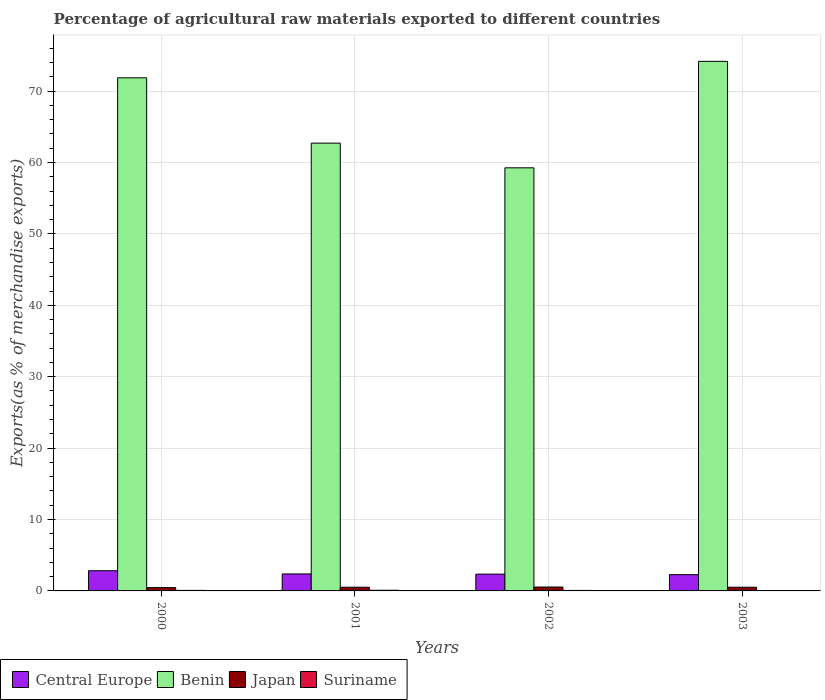Are the number of bars on each tick of the X-axis equal?
Offer a terse response. Yes. How many bars are there on the 1st tick from the right?
Offer a very short reply. 4. What is the label of the 1st group of bars from the left?
Make the answer very short. 2000. In how many cases, is the number of bars for a given year not equal to the number of legend labels?
Your answer should be very brief. 0. What is the percentage of exports to different countries in Suriname in 2002?
Your response must be concise. 0.07. Across all years, what is the maximum percentage of exports to different countries in Central Europe?
Offer a very short reply. 2.83. Across all years, what is the minimum percentage of exports to different countries in Suriname?
Make the answer very short. 0.05. In which year was the percentage of exports to different countries in Central Europe maximum?
Ensure brevity in your answer.  2000. What is the total percentage of exports to different countries in Benin in the graph?
Your answer should be very brief. 268. What is the difference between the percentage of exports to different countries in Benin in 2000 and that in 2003?
Your answer should be very brief. -2.3. What is the difference between the percentage of exports to different countries in Japan in 2001 and the percentage of exports to different countries in Suriname in 2002?
Offer a very short reply. 0.45. What is the average percentage of exports to different countries in Japan per year?
Your answer should be very brief. 0.51. In the year 2000, what is the difference between the percentage of exports to different countries in Suriname and percentage of exports to different countries in Japan?
Offer a very short reply. -0.39. What is the ratio of the percentage of exports to different countries in Benin in 2002 to that in 2003?
Your response must be concise. 0.8. What is the difference between the highest and the second highest percentage of exports to different countries in Japan?
Offer a terse response. 0.02. What is the difference between the highest and the lowest percentage of exports to different countries in Suriname?
Give a very brief answer. 0.05. In how many years, is the percentage of exports to different countries in Central Europe greater than the average percentage of exports to different countries in Central Europe taken over all years?
Keep it short and to the point. 1. Is it the case that in every year, the sum of the percentage of exports to different countries in Benin and percentage of exports to different countries in Central Europe is greater than the sum of percentage of exports to different countries in Japan and percentage of exports to different countries in Suriname?
Your answer should be very brief. Yes. What does the 2nd bar from the left in 2003 represents?
Offer a very short reply. Benin. What does the 3rd bar from the right in 2003 represents?
Keep it short and to the point. Benin. How many bars are there?
Keep it short and to the point. 16. What is the difference between two consecutive major ticks on the Y-axis?
Your response must be concise. 10. Are the values on the major ticks of Y-axis written in scientific E-notation?
Your answer should be compact. No. Does the graph contain any zero values?
Offer a very short reply. No. Where does the legend appear in the graph?
Offer a terse response. Bottom left. What is the title of the graph?
Your response must be concise. Percentage of agricultural raw materials exported to different countries. What is the label or title of the Y-axis?
Give a very brief answer. Exports(as % of merchandise exports). What is the Exports(as % of merchandise exports) of Central Europe in 2000?
Your answer should be compact. 2.83. What is the Exports(as % of merchandise exports) of Benin in 2000?
Offer a very short reply. 71.86. What is the Exports(as % of merchandise exports) of Japan in 2000?
Provide a succinct answer. 0.46. What is the Exports(as % of merchandise exports) in Suriname in 2000?
Provide a succinct answer. 0.08. What is the Exports(as % of merchandise exports) of Central Europe in 2001?
Your answer should be compact. 2.38. What is the Exports(as % of merchandise exports) in Benin in 2001?
Give a very brief answer. 62.71. What is the Exports(as % of merchandise exports) in Japan in 2001?
Keep it short and to the point. 0.52. What is the Exports(as % of merchandise exports) in Suriname in 2001?
Your response must be concise. 0.09. What is the Exports(as % of merchandise exports) in Central Europe in 2002?
Provide a succinct answer. 2.35. What is the Exports(as % of merchandise exports) in Benin in 2002?
Your answer should be very brief. 59.25. What is the Exports(as % of merchandise exports) in Japan in 2002?
Make the answer very short. 0.54. What is the Exports(as % of merchandise exports) of Suriname in 2002?
Make the answer very short. 0.07. What is the Exports(as % of merchandise exports) of Central Europe in 2003?
Your answer should be very brief. 2.28. What is the Exports(as % of merchandise exports) of Benin in 2003?
Offer a very short reply. 74.17. What is the Exports(as % of merchandise exports) of Japan in 2003?
Your answer should be compact. 0.52. What is the Exports(as % of merchandise exports) in Suriname in 2003?
Provide a short and direct response. 0.05. Across all years, what is the maximum Exports(as % of merchandise exports) in Central Europe?
Offer a terse response. 2.83. Across all years, what is the maximum Exports(as % of merchandise exports) in Benin?
Your answer should be very brief. 74.17. Across all years, what is the maximum Exports(as % of merchandise exports) of Japan?
Your answer should be very brief. 0.54. Across all years, what is the maximum Exports(as % of merchandise exports) in Suriname?
Keep it short and to the point. 0.09. Across all years, what is the minimum Exports(as % of merchandise exports) in Central Europe?
Your response must be concise. 2.28. Across all years, what is the minimum Exports(as % of merchandise exports) of Benin?
Ensure brevity in your answer.  59.25. Across all years, what is the minimum Exports(as % of merchandise exports) of Japan?
Your answer should be compact. 0.46. Across all years, what is the minimum Exports(as % of merchandise exports) in Suriname?
Keep it short and to the point. 0.05. What is the total Exports(as % of merchandise exports) in Central Europe in the graph?
Keep it short and to the point. 9.83. What is the total Exports(as % of merchandise exports) in Benin in the graph?
Offer a very short reply. 268. What is the total Exports(as % of merchandise exports) of Japan in the graph?
Offer a very short reply. 2.05. What is the total Exports(as % of merchandise exports) in Suriname in the graph?
Ensure brevity in your answer.  0.29. What is the difference between the Exports(as % of merchandise exports) of Central Europe in 2000 and that in 2001?
Your response must be concise. 0.45. What is the difference between the Exports(as % of merchandise exports) of Benin in 2000 and that in 2001?
Provide a short and direct response. 9.15. What is the difference between the Exports(as % of merchandise exports) of Japan in 2000 and that in 2001?
Keep it short and to the point. -0.06. What is the difference between the Exports(as % of merchandise exports) of Suriname in 2000 and that in 2001?
Your answer should be compact. -0.02. What is the difference between the Exports(as % of merchandise exports) of Central Europe in 2000 and that in 2002?
Your response must be concise. 0.48. What is the difference between the Exports(as % of merchandise exports) in Benin in 2000 and that in 2002?
Provide a succinct answer. 12.61. What is the difference between the Exports(as % of merchandise exports) in Japan in 2000 and that in 2002?
Provide a succinct answer. -0.08. What is the difference between the Exports(as % of merchandise exports) of Suriname in 2000 and that in 2002?
Make the answer very short. 0.01. What is the difference between the Exports(as % of merchandise exports) in Central Europe in 2000 and that in 2003?
Your answer should be very brief. 0.55. What is the difference between the Exports(as % of merchandise exports) in Benin in 2000 and that in 2003?
Give a very brief answer. -2.3. What is the difference between the Exports(as % of merchandise exports) of Japan in 2000 and that in 2003?
Provide a short and direct response. -0.05. What is the difference between the Exports(as % of merchandise exports) of Suriname in 2000 and that in 2003?
Provide a succinct answer. 0.03. What is the difference between the Exports(as % of merchandise exports) in Central Europe in 2001 and that in 2002?
Keep it short and to the point. 0.03. What is the difference between the Exports(as % of merchandise exports) of Benin in 2001 and that in 2002?
Your answer should be very brief. 3.46. What is the difference between the Exports(as % of merchandise exports) in Japan in 2001 and that in 2002?
Provide a short and direct response. -0.02. What is the difference between the Exports(as % of merchandise exports) of Suriname in 2001 and that in 2002?
Provide a succinct answer. 0.03. What is the difference between the Exports(as % of merchandise exports) of Central Europe in 2001 and that in 2003?
Give a very brief answer. 0.1. What is the difference between the Exports(as % of merchandise exports) in Benin in 2001 and that in 2003?
Offer a very short reply. -11.45. What is the difference between the Exports(as % of merchandise exports) of Japan in 2001 and that in 2003?
Give a very brief answer. 0. What is the difference between the Exports(as % of merchandise exports) in Suriname in 2001 and that in 2003?
Keep it short and to the point. 0.05. What is the difference between the Exports(as % of merchandise exports) of Central Europe in 2002 and that in 2003?
Make the answer very short. 0.07. What is the difference between the Exports(as % of merchandise exports) in Benin in 2002 and that in 2003?
Ensure brevity in your answer.  -14.91. What is the difference between the Exports(as % of merchandise exports) of Japan in 2002 and that in 2003?
Your response must be concise. 0.02. What is the difference between the Exports(as % of merchandise exports) of Suriname in 2002 and that in 2003?
Offer a terse response. 0.02. What is the difference between the Exports(as % of merchandise exports) in Central Europe in 2000 and the Exports(as % of merchandise exports) in Benin in 2001?
Offer a very short reply. -59.88. What is the difference between the Exports(as % of merchandise exports) of Central Europe in 2000 and the Exports(as % of merchandise exports) of Japan in 2001?
Your answer should be compact. 2.31. What is the difference between the Exports(as % of merchandise exports) in Central Europe in 2000 and the Exports(as % of merchandise exports) in Suriname in 2001?
Provide a succinct answer. 2.74. What is the difference between the Exports(as % of merchandise exports) in Benin in 2000 and the Exports(as % of merchandise exports) in Japan in 2001?
Offer a very short reply. 71.34. What is the difference between the Exports(as % of merchandise exports) in Benin in 2000 and the Exports(as % of merchandise exports) in Suriname in 2001?
Offer a terse response. 71.77. What is the difference between the Exports(as % of merchandise exports) of Japan in 2000 and the Exports(as % of merchandise exports) of Suriname in 2001?
Provide a succinct answer. 0.37. What is the difference between the Exports(as % of merchandise exports) in Central Europe in 2000 and the Exports(as % of merchandise exports) in Benin in 2002?
Your answer should be very brief. -56.43. What is the difference between the Exports(as % of merchandise exports) in Central Europe in 2000 and the Exports(as % of merchandise exports) in Japan in 2002?
Give a very brief answer. 2.29. What is the difference between the Exports(as % of merchandise exports) of Central Europe in 2000 and the Exports(as % of merchandise exports) of Suriname in 2002?
Your answer should be very brief. 2.76. What is the difference between the Exports(as % of merchandise exports) in Benin in 2000 and the Exports(as % of merchandise exports) in Japan in 2002?
Offer a very short reply. 71.32. What is the difference between the Exports(as % of merchandise exports) in Benin in 2000 and the Exports(as % of merchandise exports) in Suriname in 2002?
Offer a very short reply. 71.79. What is the difference between the Exports(as % of merchandise exports) of Japan in 2000 and the Exports(as % of merchandise exports) of Suriname in 2002?
Provide a succinct answer. 0.4. What is the difference between the Exports(as % of merchandise exports) in Central Europe in 2000 and the Exports(as % of merchandise exports) in Benin in 2003?
Provide a succinct answer. -71.34. What is the difference between the Exports(as % of merchandise exports) of Central Europe in 2000 and the Exports(as % of merchandise exports) of Japan in 2003?
Your answer should be very brief. 2.31. What is the difference between the Exports(as % of merchandise exports) in Central Europe in 2000 and the Exports(as % of merchandise exports) in Suriname in 2003?
Your answer should be compact. 2.78. What is the difference between the Exports(as % of merchandise exports) in Benin in 2000 and the Exports(as % of merchandise exports) in Japan in 2003?
Your answer should be very brief. 71.34. What is the difference between the Exports(as % of merchandise exports) of Benin in 2000 and the Exports(as % of merchandise exports) of Suriname in 2003?
Your answer should be compact. 71.82. What is the difference between the Exports(as % of merchandise exports) in Japan in 2000 and the Exports(as % of merchandise exports) in Suriname in 2003?
Provide a short and direct response. 0.42. What is the difference between the Exports(as % of merchandise exports) of Central Europe in 2001 and the Exports(as % of merchandise exports) of Benin in 2002?
Your answer should be very brief. -56.88. What is the difference between the Exports(as % of merchandise exports) in Central Europe in 2001 and the Exports(as % of merchandise exports) in Japan in 2002?
Keep it short and to the point. 1.83. What is the difference between the Exports(as % of merchandise exports) of Central Europe in 2001 and the Exports(as % of merchandise exports) of Suriname in 2002?
Give a very brief answer. 2.31. What is the difference between the Exports(as % of merchandise exports) of Benin in 2001 and the Exports(as % of merchandise exports) of Japan in 2002?
Offer a very short reply. 62.17. What is the difference between the Exports(as % of merchandise exports) of Benin in 2001 and the Exports(as % of merchandise exports) of Suriname in 2002?
Give a very brief answer. 62.65. What is the difference between the Exports(as % of merchandise exports) in Japan in 2001 and the Exports(as % of merchandise exports) in Suriname in 2002?
Your response must be concise. 0.45. What is the difference between the Exports(as % of merchandise exports) in Central Europe in 2001 and the Exports(as % of merchandise exports) in Benin in 2003?
Give a very brief answer. -71.79. What is the difference between the Exports(as % of merchandise exports) of Central Europe in 2001 and the Exports(as % of merchandise exports) of Japan in 2003?
Offer a terse response. 1.86. What is the difference between the Exports(as % of merchandise exports) in Central Europe in 2001 and the Exports(as % of merchandise exports) in Suriname in 2003?
Provide a short and direct response. 2.33. What is the difference between the Exports(as % of merchandise exports) in Benin in 2001 and the Exports(as % of merchandise exports) in Japan in 2003?
Offer a very short reply. 62.2. What is the difference between the Exports(as % of merchandise exports) of Benin in 2001 and the Exports(as % of merchandise exports) of Suriname in 2003?
Your response must be concise. 62.67. What is the difference between the Exports(as % of merchandise exports) of Japan in 2001 and the Exports(as % of merchandise exports) of Suriname in 2003?
Your answer should be very brief. 0.47. What is the difference between the Exports(as % of merchandise exports) in Central Europe in 2002 and the Exports(as % of merchandise exports) in Benin in 2003?
Your answer should be compact. -71.82. What is the difference between the Exports(as % of merchandise exports) in Central Europe in 2002 and the Exports(as % of merchandise exports) in Japan in 2003?
Provide a succinct answer. 1.83. What is the difference between the Exports(as % of merchandise exports) in Central Europe in 2002 and the Exports(as % of merchandise exports) in Suriname in 2003?
Offer a terse response. 2.3. What is the difference between the Exports(as % of merchandise exports) of Benin in 2002 and the Exports(as % of merchandise exports) of Japan in 2003?
Provide a succinct answer. 58.74. What is the difference between the Exports(as % of merchandise exports) of Benin in 2002 and the Exports(as % of merchandise exports) of Suriname in 2003?
Offer a very short reply. 59.21. What is the difference between the Exports(as % of merchandise exports) of Japan in 2002 and the Exports(as % of merchandise exports) of Suriname in 2003?
Offer a very short reply. 0.5. What is the average Exports(as % of merchandise exports) in Central Europe per year?
Provide a short and direct response. 2.46. What is the average Exports(as % of merchandise exports) of Benin per year?
Offer a very short reply. 67. What is the average Exports(as % of merchandise exports) of Japan per year?
Keep it short and to the point. 0.51. What is the average Exports(as % of merchandise exports) in Suriname per year?
Provide a short and direct response. 0.07. In the year 2000, what is the difference between the Exports(as % of merchandise exports) of Central Europe and Exports(as % of merchandise exports) of Benin?
Keep it short and to the point. -69.03. In the year 2000, what is the difference between the Exports(as % of merchandise exports) of Central Europe and Exports(as % of merchandise exports) of Japan?
Provide a short and direct response. 2.36. In the year 2000, what is the difference between the Exports(as % of merchandise exports) in Central Europe and Exports(as % of merchandise exports) in Suriname?
Your answer should be compact. 2.75. In the year 2000, what is the difference between the Exports(as % of merchandise exports) in Benin and Exports(as % of merchandise exports) in Japan?
Make the answer very short. 71.4. In the year 2000, what is the difference between the Exports(as % of merchandise exports) in Benin and Exports(as % of merchandise exports) in Suriname?
Offer a very short reply. 71.78. In the year 2000, what is the difference between the Exports(as % of merchandise exports) of Japan and Exports(as % of merchandise exports) of Suriname?
Offer a terse response. 0.39. In the year 2001, what is the difference between the Exports(as % of merchandise exports) in Central Europe and Exports(as % of merchandise exports) in Benin?
Ensure brevity in your answer.  -60.34. In the year 2001, what is the difference between the Exports(as % of merchandise exports) in Central Europe and Exports(as % of merchandise exports) in Japan?
Give a very brief answer. 1.86. In the year 2001, what is the difference between the Exports(as % of merchandise exports) of Central Europe and Exports(as % of merchandise exports) of Suriname?
Provide a succinct answer. 2.28. In the year 2001, what is the difference between the Exports(as % of merchandise exports) in Benin and Exports(as % of merchandise exports) in Japan?
Offer a very short reply. 62.19. In the year 2001, what is the difference between the Exports(as % of merchandise exports) in Benin and Exports(as % of merchandise exports) in Suriname?
Your response must be concise. 62.62. In the year 2001, what is the difference between the Exports(as % of merchandise exports) in Japan and Exports(as % of merchandise exports) in Suriname?
Your response must be concise. 0.43. In the year 2002, what is the difference between the Exports(as % of merchandise exports) in Central Europe and Exports(as % of merchandise exports) in Benin?
Keep it short and to the point. -56.91. In the year 2002, what is the difference between the Exports(as % of merchandise exports) in Central Europe and Exports(as % of merchandise exports) in Japan?
Your response must be concise. 1.81. In the year 2002, what is the difference between the Exports(as % of merchandise exports) in Central Europe and Exports(as % of merchandise exports) in Suriname?
Your answer should be very brief. 2.28. In the year 2002, what is the difference between the Exports(as % of merchandise exports) of Benin and Exports(as % of merchandise exports) of Japan?
Keep it short and to the point. 58.71. In the year 2002, what is the difference between the Exports(as % of merchandise exports) of Benin and Exports(as % of merchandise exports) of Suriname?
Provide a succinct answer. 59.19. In the year 2002, what is the difference between the Exports(as % of merchandise exports) in Japan and Exports(as % of merchandise exports) in Suriname?
Offer a very short reply. 0.47. In the year 2003, what is the difference between the Exports(as % of merchandise exports) in Central Europe and Exports(as % of merchandise exports) in Benin?
Keep it short and to the point. -71.89. In the year 2003, what is the difference between the Exports(as % of merchandise exports) in Central Europe and Exports(as % of merchandise exports) in Japan?
Your response must be concise. 1.76. In the year 2003, what is the difference between the Exports(as % of merchandise exports) of Central Europe and Exports(as % of merchandise exports) of Suriname?
Provide a succinct answer. 2.23. In the year 2003, what is the difference between the Exports(as % of merchandise exports) in Benin and Exports(as % of merchandise exports) in Japan?
Give a very brief answer. 73.65. In the year 2003, what is the difference between the Exports(as % of merchandise exports) of Benin and Exports(as % of merchandise exports) of Suriname?
Offer a terse response. 74.12. In the year 2003, what is the difference between the Exports(as % of merchandise exports) of Japan and Exports(as % of merchandise exports) of Suriname?
Offer a very short reply. 0.47. What is the ratio of the Exports(as % of merchandise exports) in Central Europe in 2000 to that in 2001?
Provide a succinct answer. 1.19. What is the ratio of the Exports(as % of merchandise exports) in Benin in 2000 to that in 2001?
Your answer should be very brief. 1.15. What is the ratio of the Exports(as % of merchandise exports) of Japan in 2000 to that in 2001?
Make the answer very short. 0.89. What is the ratio of the Exports(as % of merchandise exports) in Suriname in 2000 to that in 2001?
Your answer should be very brief. 0.84. What is the ratio of the Exports(as % of merchandise exports) of Central Europe in 2000 to that in 2002?
Your response must be concise. 1.2. What is the ratio of the Exports(as % of merchandise exports) of Benin in 2000 to that in 2002?
Your answer should be very brief. 1.21. What is the ratio of the Exports(as % of merchandise exports) of Japan in 2000 to that in 2002?
Your answer should be very brief. 0.86. What is the ratio of the Exports(as % of merchandise exports) of Suriname in 2000 to that in 2002?
Ensure brevity in your answer.  1.14. What is the ratio of the Exports(as % of merchandise exports) in Central Europe in 2000 to that in 2003?
Your answer should be very brief. 1.24. What is the ratio of the Exports(as % of merchandise exports) of Benin in 2000 to that in 2003?
Offer a terse response. 0.97. What is the ratio of the Exports(as % of merchandise exports) in Japan in 2000 to that in 2003?
Keep it short and to the point. 0.9. What is the ratio of the Exports(as % of merchandise exports) in Suriname in 2000 to that in 2003?
Your response must be concise. 1.67. What is the ratio of the Exports(as % of merchandise exports) in Central Europe in 2001 to that in 2002?
Your response must be concise. 1.01. What is the ratio of the Exports(as % of merchandise exports) of Benin in 2001 to that in 2002?
Offer a terse response. 1.06. What is the ratio of the Exports(as % of merchandise exports) in Japan in 2001 to that in 2002?
Make the answer very short. 0.96. What is the ratio of the Exports(as % of merchandise exports) of Suriname in 2001 to that in 2002?
Your answer should be compact. 1.37. What is the ratio of the Exports(as % of merchandise exports) of Central Europe in 2001 to that in 2003?
Your answer should be compact. 1.04. What is the ratio of the Exports(as % of merchandise exports) in Benin in 2001 to that in 2003?
Make the answer very short. 0.85. What is the ratio of the Exports(as % of merchandise exports) of Suriname in 2001 to that in 2003?
Ensure brevity in your answer.  2. What is the ratio of the Exports(as % of merchandise exports) in Central Europe in 2002 to that in 2003?
Ensure brevity in your answer.  1.03. What is the ratio of the Exports(as % of merchandise exports) in Benin in 2002 to that in 2003?
Offer a terse response. 0.8. What is the ratio of the Exports(as % of merchandise exports) of Japan in 2002 to that in 2003?
Keep it short and to the point. 1.05. What is the ratio of the Exports(as % of merchandise exports) of Suriname in 2002 to that in 2003?
Make the answer very short. 1.46. What is the difference between the highest and the second highest Exports(as % of merchandise exports) of Central Europe?
Your answer should be compact. 0.45. What is the difference between the highest and the second highest Exports(as % of merchandise exports) of Benin?
Offer a terse response. 2.3. What is the difference between the highest and the second highest Exports(as % of merchandise exports) of Japan?
Ensure brevity in your answer.  0.02. What is the difference between the highest and the second highest Exports(as % of merchandise exports) in Suriname?
Ensure brevity in your answer.  0.02. What is the difference between the highest and the lowest Exports(as % of merchandise exports) of Central Europe?
Keep it short and to the point. 0.55. What is the difference between the highest and the lowest Exports(as % of merchandise exports) of Benin?
Your answer should be very brief. 14.91. What is the difference between the highest and the lowest Exports(as % of merchandise exports) in Japan?
Your answer should be compact. 0.08. What is the difference between the highest and the lowest Exports(as % of merchandise exports) in Suriname?
Provide a succinct answer. 0.05. 